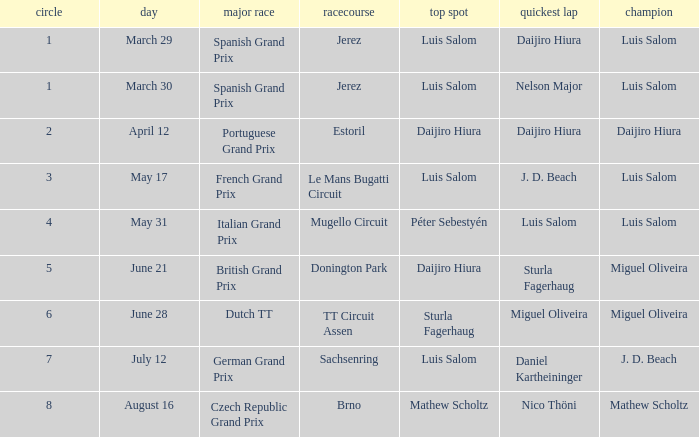Luis Salom had the fastest lap on which circuits?  Mugello Circuit. 